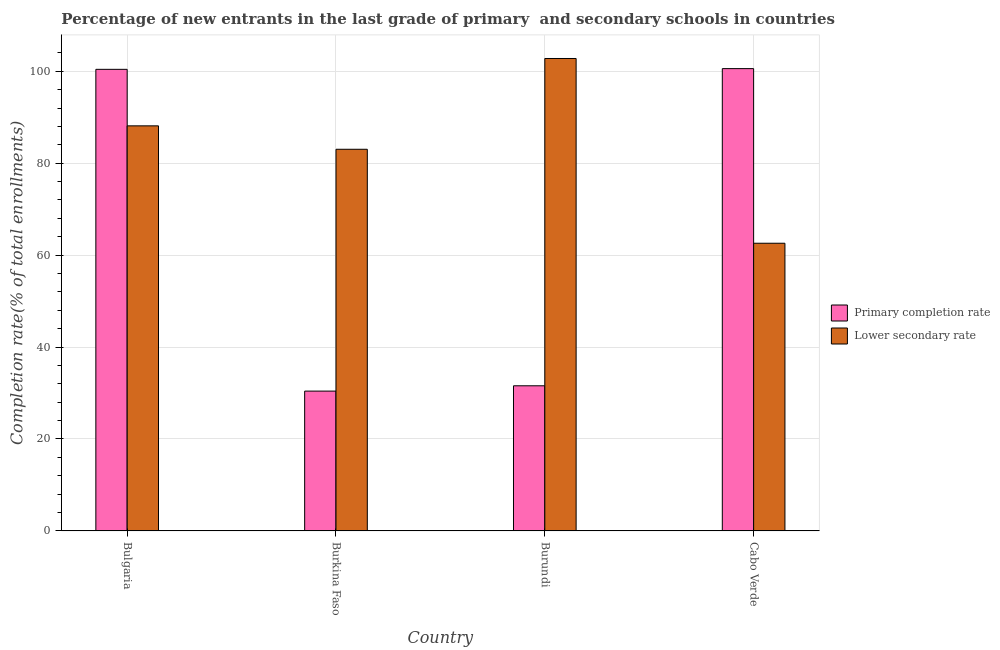Are the number of bars per tick equal to the number of legend labels?
Make the answer very short. Yes. What is the label of the 2nd group of bars from the left?
Provide a succinct answer. Burkina Faso. In how many cases, is the number of bars for a given country not equal to the number of legend labels?
Give a very brief answer. 0. What is the completion rate in secondary schools in Burkina Faso?
Make the answer very short. 83.02. Across all countries, what is the maximum completion rate in secondary schools?
Your answer should be compact. 102.77. Across all countries, what is the minimum completion rate in primary schools?
Provide a succinct answer. 30.42. In which country was the completion rate in primary schools maximum?
Give a very brief answer. Cabo Verde. In which country was the completion rate in primary schools minimum?
Make the answer very short. Burkina Faso. What is the total completion rate in primary schools in the graph?
Keep it short and to the point. 262.98. What is the difference between the completion rate in secondary schools in Bulgaria and that in Burkina Faso?
Offer a terse response. 5.1. What is the difference between the completion rate in secondary schools in Burkina Faso and the completion rate in primary schools in Burundi?
Your answer should be very brief. 51.45. What is the average completion rate in primary schools per country?
Give a very brief answer. 65.74. What is the difference between the completion rate in secondary schools and completion rate in primary schools in Burundi?
Offer a terse response. 71.2. What is the ratio of the completion rate in secondary schools in Burundi to that in Cabo Verde?
Provide a succinct answer. 1.64. Is the completion rate in secondary schools in Bulgaria less than that in Cabo Verde?
Offer a terse response. No. What is the difference between the highest and the second highest completion rate in secondary schools?
Your answer should be compact. 14.65. What is the difference between the highest and the lowest completion rate in primary schools?
Offer a very short reply. 70.15. Is the sum of the completion rate in secondary schools in Burkina Faso and Cabo Verde greater than the maximum completion rate in primary schools across all countries?
Ensure brevity in your answer.  Yes. What does the 1st bar from the left in Burundi represents?
Your response must be concise. Primary completion rate. What does the 1st bar from the right in Burundi represents?
Ensure brevity in your answer.  Lower secondary rate. What is the difference between two consecutive major ticks on the Y-axis?
Make the answer very short. 20. Does the graph contain grids?
Make the answer very short. Yes. What is the title of the graph?
Offer a terse response. Percentage of new entrants in the last grade of primary  and secondary schools in countries. Does "Secondary education" appear as one of the legend labels in the graph?
Keep it short and to the point. No. What is the label or title of the X-axis?
Your answer should be very brief. Country. What is the label or title of the Y-axis?
Provide a short and direct response. Completion rate(% of total enrollments). What is the Completion rate(% of total enrollments) in Primary completion rate in Bulgaria?
Keep it short and to the point. 100.41. What is the Completion rate(% of total enrollments) in Lower secondary rate in Bulgaria?
Your answer should be very brief. 88.12. What is the Completion rate(% of total enrollments) of Primary completion rate in Burkina Faso?
Your answer should be very brief. 30.42. What is the Completion rate(% of total enrollments) in Lower secondary rate in Burkina Faso?
Your response must be concise. 83.02. What is the Completion rate(% of total enrollments) of Primary completion rate in Burundi?
Make the answer very short. 31.57. What is the Completion rate(% of total enrollments) of Lower secondary rate in Burundi?
Your answer should be very brief. 102.77. What is the Completion rate(% of total enrollments) in Primary completion rate in Cabo Verde?
Keep it short and to the point. 100.57. What is the Completion rate(% of total enrollments) in Lower secondary rate in Cabo Verde?
Provide a short and direct response. 62.58. Across all countries, what is the maximum Completion rate(% of total enrollments) in Primary completion rate?
Ensure brevity in your answer.  100.57. Across all countries, what is the maximum Completion rate(% of total enrollments) in Lower secondary rate?
Ensure brevity in your answer.  102.77. Across all countries, what is the minimum Completion rate(% of total enrollments) of Primary completion rate?
Your response must be concise. 30.42. Across all countries, what is the minimum Completion rate(% of total enrollments) of Lower secondary rate?
Your answer should be very brief. 62.58. What is the total Completion rate(% of total enrollments) in Primary completion rate in the graph?
Give a very brief answer. 262.98. What is the total Completion rate(% of total enrollments) in Lower secondary rate in the graph?
Offer a very short reply. 336.5. What is the difference between the Completion rate(% of total enrollments) in Primary completion rate in Bulgaria and that in Burkina Faso?
Offer a very short reply. 69.99. What is the difference between the Completion rate(% of total enrollments) of Lower secondary rate in Bulgaria and that in Burkina Faso?
Your response must be concise. 5.1. What is the difference between the Completion rate(% of total enrollments) of Primary completion rate in Bulgaria and that in Burundi?
Give a very brief answer. 68.84. What is the difference between the Completion rate(% of total enrollments) in Lower secondary rate in Bulgaria and that in Burundi?
Your answer should be compact. -14.65. What is the difference between the Completion rate(% of total enrollments) in Primary completion rate in Bulgaria and that in Cabo Verde?
Provide a short and direct response. -0.16. What is the difference between the Completion rate(% of total enrollments) in Lower secondary rate in Bulgaria and that in Cabo Verde?
Your answer should be very brief. 25.54. What is the difference between the Completion rate(% of total enrollments) in Primary completion rate in Burkina Faso and that in Burundi?
Offer a very short reply. -1.15. What is the difference between the Completion rate(% of total enrollments) in Lower secondary rate in Burkina Faso and that in Burundi?
Provide a short and direct response. -19.75. What is the difference between the Completion rate(% of total enrollments) in Primary completion rate in Burkina Faso and that in Cabo Verde?
Your response must be concise. -70.15. What is the difference between the Completion rate(% of total enrollments) of Lower secondary rate in Burkina Faso and that in Cabo Verde?
Provide a short and direct response. 20.44. What is the difference between the Completion rate(% of total enrollments) of Primary completion rate in Burundi and that in Cabo Verde?
Provide a succinct answer. -69. What is the difference between the Completion rate(% of total enrollments) in Lower secondary rate in Burundi and that in Cabo Verde?
Keep it short and to the point. 40.19. What is the difference between the Completion rate(% of total enrollments) of Primary completion rate in Bulgaria and the Completion rate(% of total enrollments) of Lower secondary rate in Burkina Faso?
Give a very brief answer. 17.39. What is the difference between the Completion rate(% of total enrollments) of Primary completion rate in Bulgaria and the Completion rate(% of total enrollments) of Lower secondary rate in Burundi?
Ensure brevity in your answer.  -2.36. What is the difference between the Completion rate(% of total enrollments) of Primary completion rate in Bulgaria and the Completion rate(% of total enrollments) of Lower secondary rate in Cabo Verde?
Provide a succinct answer. 37.83. What is the difference between the Completion rate(% of total enrollments) in Primary completion rate in Burkina Faso and the Completion rate(% of total enrollments) in Lower secondary rate in Burundi?
Provide a succinct answer. -72.35. What is the difference between the Completion rate(% of total enrollments) in Primary completion rate in Burkina Faso and the Completion rate(% of total enrollments) in Lower secondary rate in Cabo Verde?
Give a very brief answer. -32.16. What is the difference between the Completion rate(% of total enrollments) of Primary completion rate in Burundi and the Completion rate(% of total enrollments) of Lower secondary rate in Cabo Verde?
Provide a succinct answer. -31.01. What is the average Completion rate(% of total enrollments) of Primary completion rate per country?
Offer a very short reply. 65.74. What is the average Completion rate(% of total enrollments) in Lower secondary rate per country?
Your answer should be very brief. 84.12. What is the difference between the Completion rate(% of total enrollments) in Primary completion rate and Completion rate(% of total enrollments) in Lower secondary rate in Bulgaria?
Your response must be concise. 12.29. What is the difference between the Completion rate(% of total enrollments) in Primary completion rate and Completion rate(% of total enrollments) in Lower secondary rate in Burkina Faso?
Make the answer very short. -52.6. What is the difference between the Completion rate(% of total enrollments) of Primary completion rate and Completion rate(% of total enrollments) of Lower secondary rate in Burundi?
Your response must be concise. -71.2. What is the difference between the Completion rate(% of total enrollments) of Primary completion rate and Completion rate(% of total enrollments) of Lower secondary rate in Cabo Verde?
Give a very brief answer. 37.99. What is the ratio of the Completion rate(% of total enrollments) in Primary completion rate in Bulgaria to that in Burkina Faso?
Give a very brief answer. 3.3. What is the ratio of the Completion rate(% of total enrollments) in Lower secondary rate in Bulgaria to that in Burkina Faso?
Provide a succinct answer. 1.06. What is the ratio of the Completion rate(% of total enrollments) in Primary completion rate in Bulgaria to that in Burundi?
Give a very brief answer. 3.18. What is the ratio of the Completion rate(% of total enrollments) in Lower secondary rate in Bulgaria to that in Burundi?
Offer a terse response. 0.86. What is the ratio of the Completion rate(% of total enrollments) in Lower secondary rate in Bulgaria to that in Cabo Verde?
Your answer should be very brief. 1.41. What is the ratio of the Completion rate(% of total enrollments) of Primary completion rate in Burkina Faso to that in Burundi?
Give a very brief answer. 0.96. What is the ratio of the Completion rate(% of total enrollments) in Lower secondary rate in Burkina Faso to that in Burundi?
Offer a terse response. 0.81. What is the ratio of the Completion rate(% of total enrollments) of Primary completion rate in Burkina Faso to that in Cabo Verde?
Your answer should be compact. 0.3. What is the ratio of the Completion rate(% of total enrollments) of Lower secondary rate in Burkina Faso to that in Cabo Verde?
Offer a terse response. 1.33. What is the ratio of the Completion rate(% of total enrollments) in Primary completion rate in Burundi to that in Cabo Verde?
Give a very brief answer. 0.31. What is the ratio of the Completion rate(% of total enrollments) of Lower secondary rate in Burundi to that in Cabo Verde?
Your answer should be compact. 1.64. What is the difference between the highest and the second highest Completion rate(% of total enrollments) of Primary completion rate?
Keep it short and to the point. 0.16. What is the difference between the highest and the second highest Completion rate(% of total enrollments) in Lower secondary rate?
Give a very brief answer. 14.65. What is the difference between the highest and the lowest Completion rate(% of total enrollments) in Primary completion rate?
Provide a succinct answer. 70.15. What is the difference between the highest and the lowest Completion rate(% of total enrollments) in Lower secondary rate?
Give a very brief answer. 40.19. 